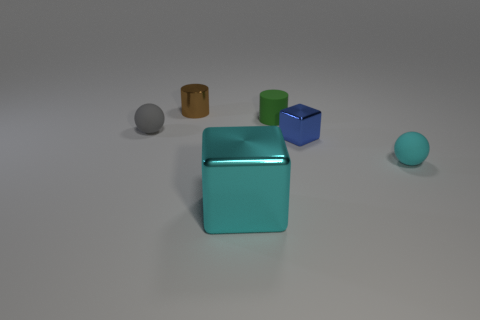Add 1 blue metal balls. How many objects exist? 7 Subtract all balls. How many objects are left? 4 Add 5 large gray shiny spheres. How many large gray shiny spheres exist? 5 Subtract 0 purple cylinders. How many objects are left? 6 Subtract all tiny brown cylinders. Subtract all blue objects. How many objects are left? 4 Add 1 small brown metallic things. How many small brown metallic things are left? 2 